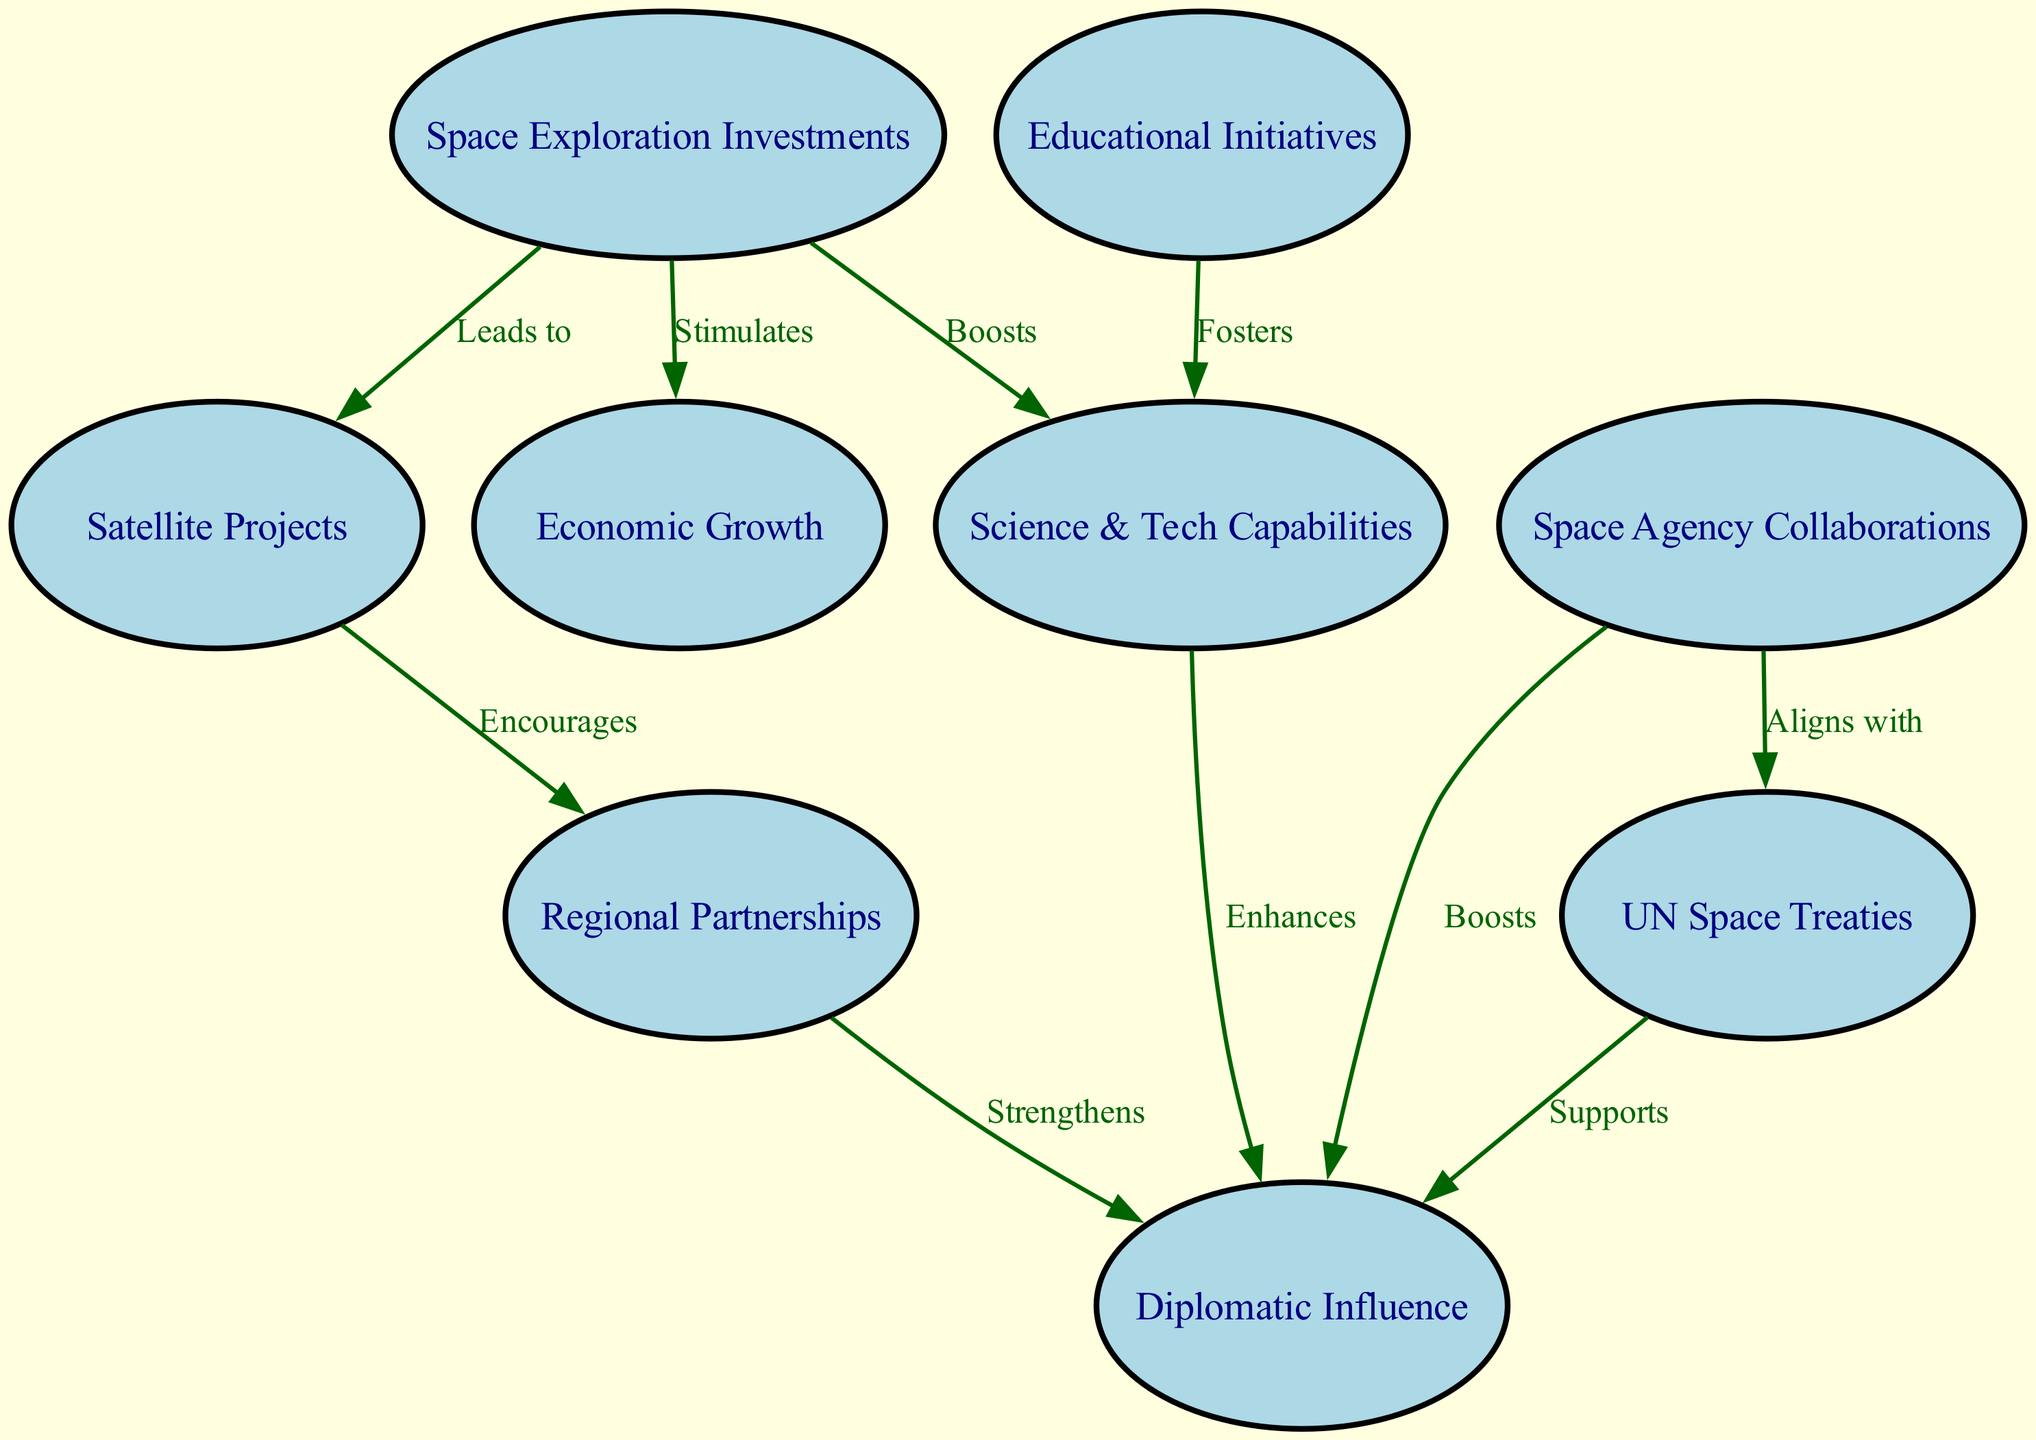What are the main nodes present in the diagram? The diagram consists of the following nodes: Space Exploration Investments, Science & Tech Capabilities, Diplomatic Influence, Satellite Projects, UN Space Treaties, Regional Partnerships, Economic Growth, Educational Initiatives, and Space Agency Collaborations.
Answer: Space Exploration Investments, Science & Tech Capabilities, Diplomatic Influence, Satellite Projects, UN Space Treaties, Regional Partnerships, Economic Growth, Educational Initiatives, Space Agency Collaborations How many edges are in the diagram? By counting the connections, the edges represent the relationships and there are a total of 10 edges in the diagram that link the nodes.
Answer: 10 What relationship does Space Exploration Investments have with Economic Growth? The diagram shows that Space Exploration Investments "Stimulates" Economic Growth, indicating a positive influence of investments in space exploration on economic aspects.
Answer: Stimulates How does Science & Tech Capabilities relate to Diplomatic Influence? Science & Tech Capabilities "Enhances" Diplomatic Influence, meaning improvements or advancements in science and technology could increase a country's ability to exert diplomatic power.
Answer: Enhances What effect do Regional Partnerships have on Diplomatic Influence? Regional Partnerships "Strengthen" Diplomatic Influence, suggesting that collaboration among neighboring countries can bolster their collective diplomatic standing.
Answer: Strengthens If a country invests in Space Exploration, what is one potential outcome regarding Satellites? The diagram indicates that investment in Space Exploration "Leads to" the development of Satellite Projects, which implies that such investments typically result in satellite initiatives.
Answer: Leads to Which node conveys the relationship between Space Agency Collaborations and UN Space Treaties? The diagram states that Space Agency Collaborations "Aligns with" UN Space Treaties, indicating that cooperative efforts among space agencies are in agreement with global regulations regarding space.
Answer: Aligns with What node directly supports Diplomatic Influence? The diagram depicts that both UN Space Treaties and Space Agency Collaborations have connections that "Support" Diplomatic Influence, highlighting their roles in enhancing diplomatic relationships.
Answer: Supports 